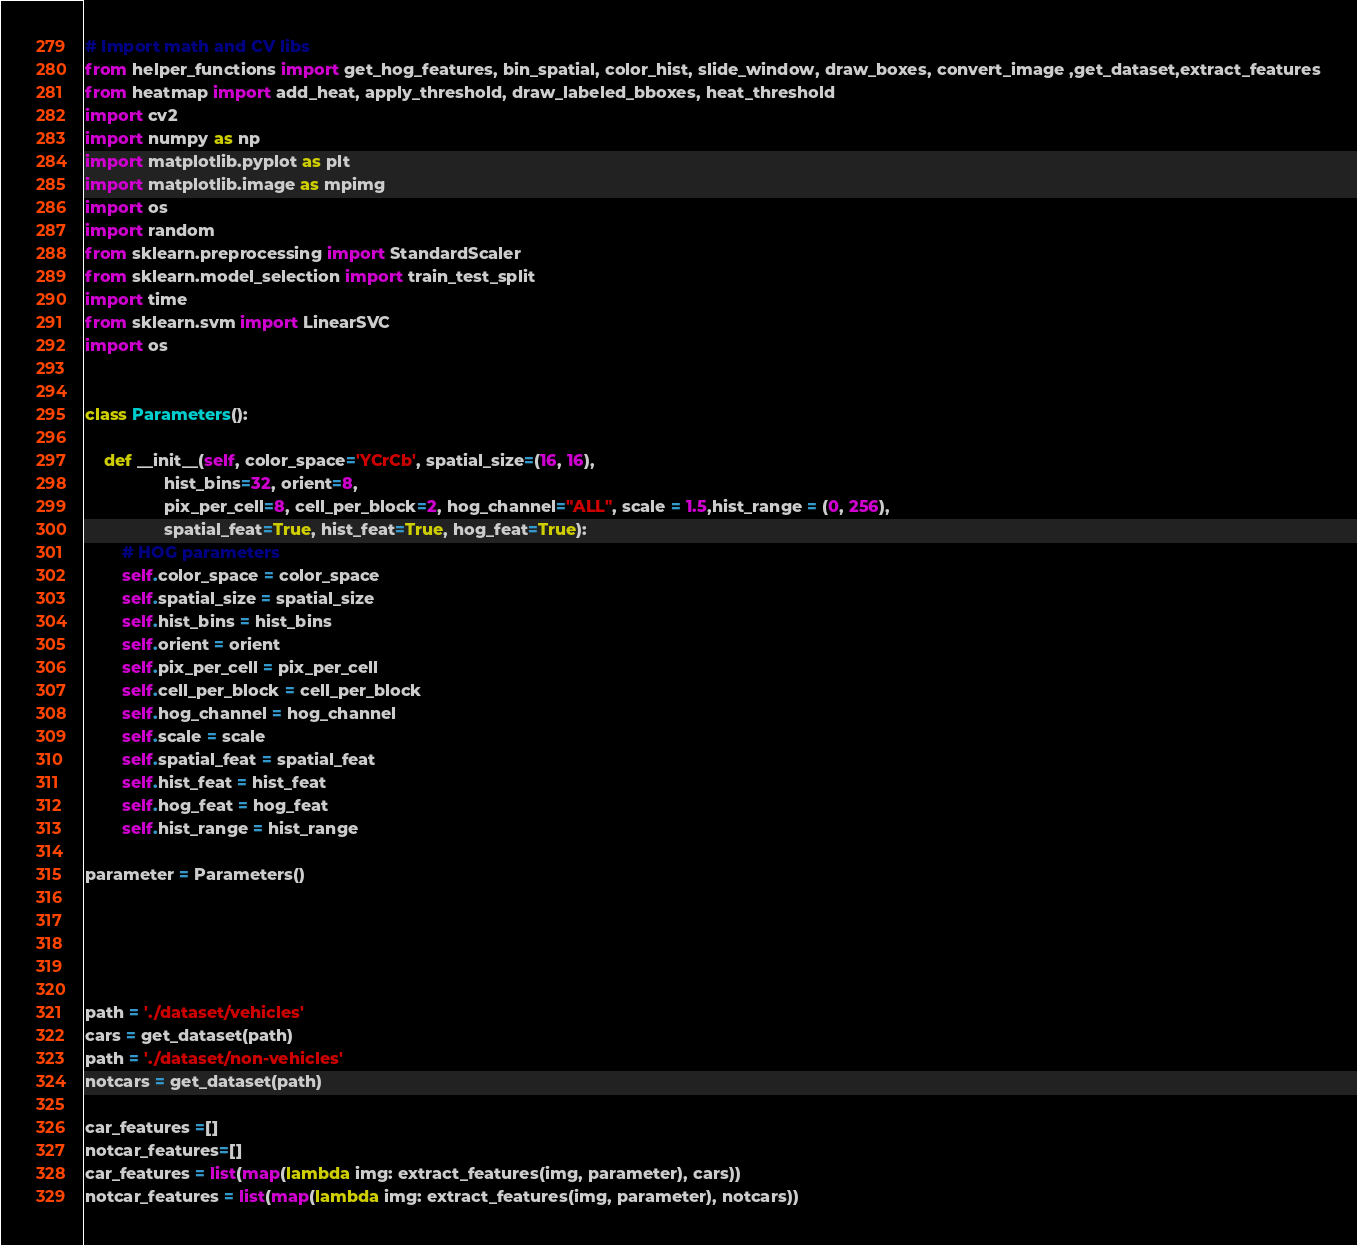Convert code to text. <code><loc_0><loc_0><loc_500><loc_500><_Python_>
# Import math and CV libs
from helper_functions import get_hog_features, bin_spatial, color_hist, slide_window, draw_boxes, convert_image ,get_dataset,extract_features
from heatmap import add_heat, apply_threshold, draw_labeled_bboxes, heat_threshold
import cv2
import numpy as np
import matplotlib.pyplot as plt
import matplotlib.image as mpimg
import os
import random
from sklearn.preprocessing import StandardScaler
from sklearn.model_selection import train_test_split
import time
from sklearn.svm import LinearSVC
import os


class Parameters():

    def __init__(self, color_space='YCrCb', spatial_size=(16, 16),
                 hist_bins=32, orient=8, 
                 pix_per_cell=8, cell_per_block=2, hog_channel="ALL", scale = 1.5,hist_range = (0, 256),
                 spatial_feat=True, hist_feat=True, hog_feat=True):
        # HOG parameters
        self.color_space = color_space
        self.spatial_size = spatial_size
        self.hist_bins = hist_bins
        self.orient = orient
        self.pix_per_cell = pix_per_cell
        self.cell_per_block = cell_per_block
        self.hog_channel = hog_channel
        self.scale = scale
        self.spatial_feat = spatial_feat
        self.hist_feat = hist_feat
        self.hog_feat = hog_feat
        self.hist_range = hist_range

parameter = Parameters()





path = './dataset/vehicles'
cars = get_dataset(path)
path = './dataset/non-vehicles'
notcars = get_dataset(path)

car_features =[]
notcar_features=[]
car_features = list(map(lambda img: extract_features(img, parameter), cars))
notcar_features = list(map(lambda img: extract_features(img, parameter), notcars))

</code> 